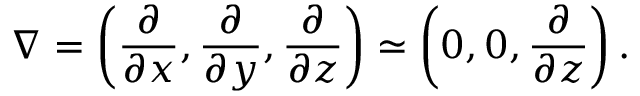Convert formula to latex. <formula><loc_0><loc_0><loc_500><loc_500>\nabla = \left ( { \frac { \partial } { \partial x } , \frac { \partial } { \partial y } , \frac { \partial } { \partial z } } \right ) \simeq \left ( { 0 , 0 , \frac { \partial } { \partial z } } \right ) .</formula> 